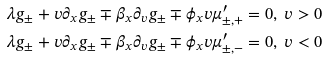<formula> <loc_0><loc_0><loc_500><loc_500>\lambda g _ { \pm } + v \partial _ { x } g _ { \pm } \mp \beta _ { x } \partial _ { v } g _ { \pm } \mp \phi _ { x } v \mu _ { \pm , + } ^ { \prime } & = 0 , \ v > 0 \\ \lambda g _ { \pm } + v \partial _ { x } g _ { \pm } \mp \beta _ { x } \partial _ { v } g _ { \pm } \mp \phi _ { x } v \mu _ { \pm , - } ^ { \prime } & = 0 , \ v < 0</formula> 